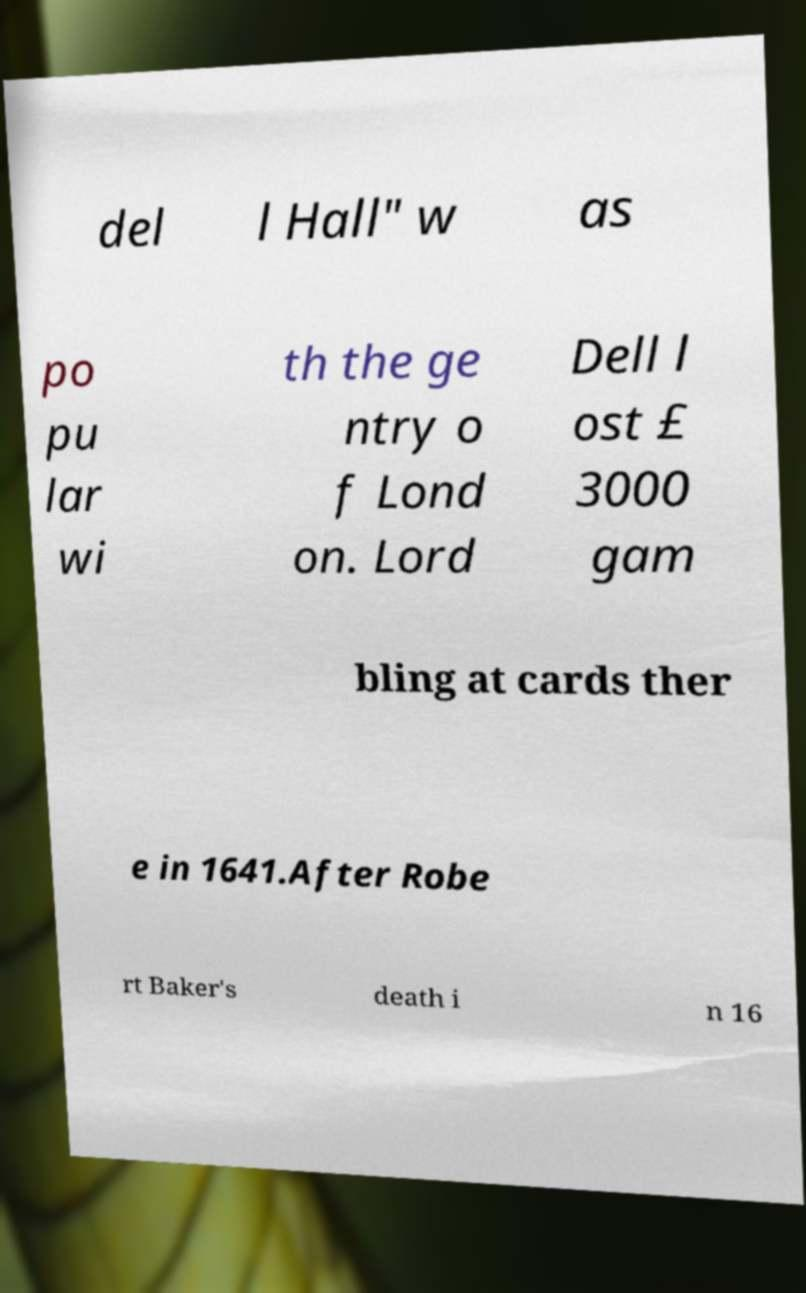I need the written content from this picture converted into text. Can you do that? del l Hall" w as po pu lar wi th the ge ntry o f Lond on. Lord Dell l ost £ 3000 gam bling at cards ther e in 1641.After Robe rt Baker's death i n 16 